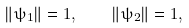Convert formula to latex. <formula><loc_0><loc_0><loc_500><loc_500>\left \| \psi _ { 1 } \right \| = 1 , \quad \left \| \psi _ { 2 } \right \| = 1 ,</formula> 